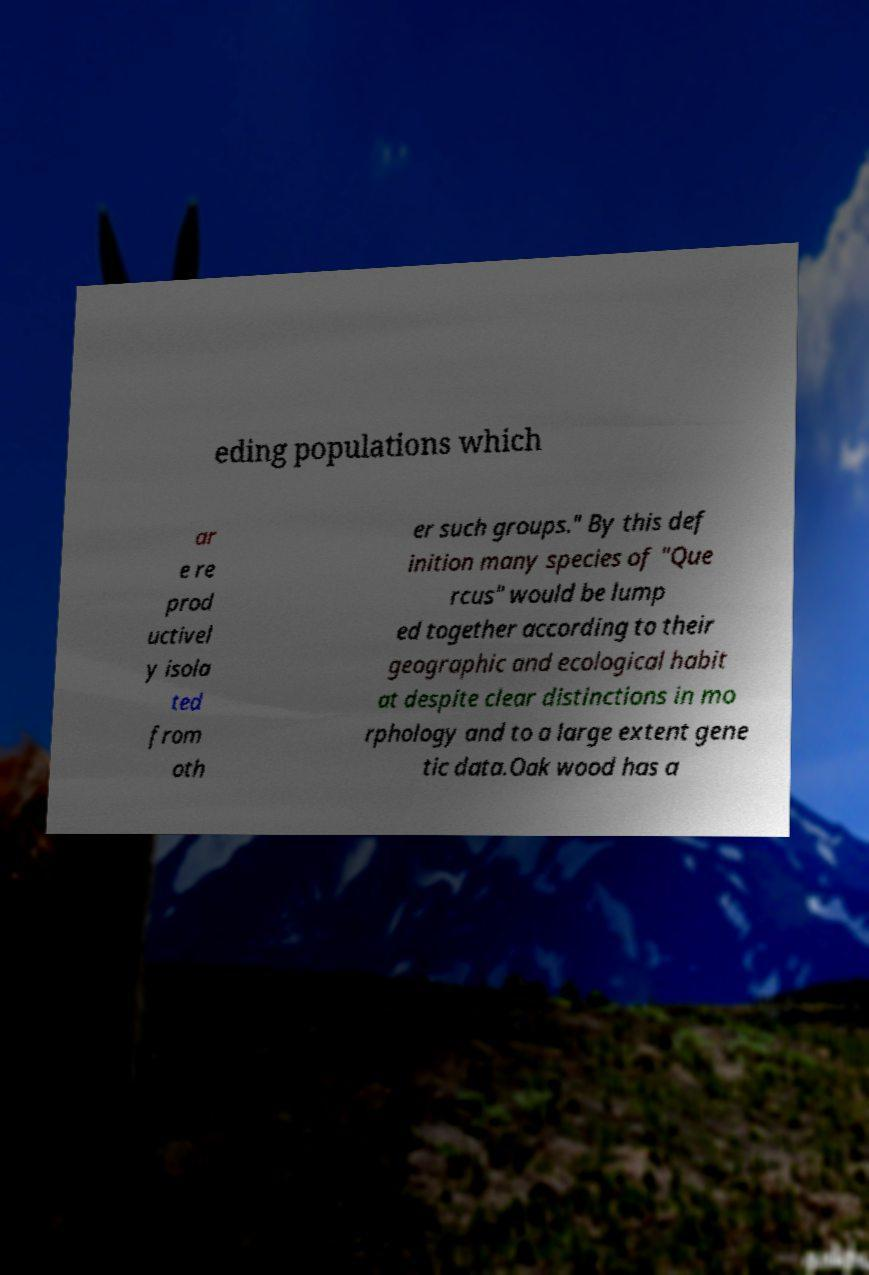What messages or text are displayed in this image? I need them in a readable, typed format. eding populations which ar e re prod uctivel y isola ted from oth er such groups." By this def inition many species of "Que rcus" would be lump ed together according to their geographic and ecological habit at despite clear distinctions in mo rphology and to a large extent gene tic data.Oak wood has a 